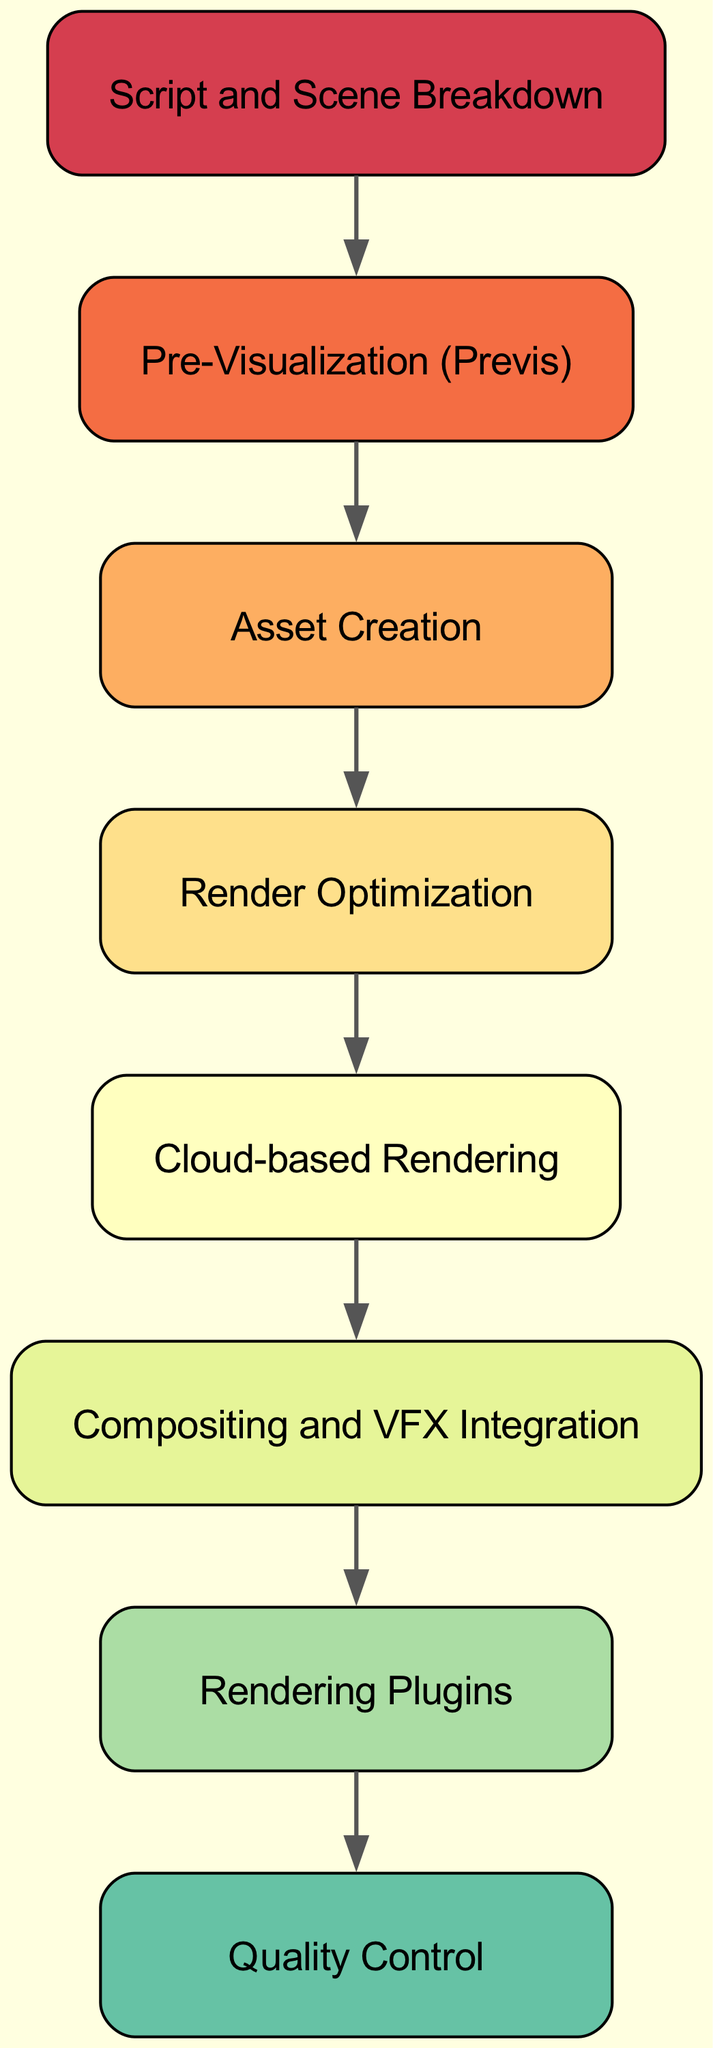What is the first process in the diagram? The first process listed in the diagram is "Script and Scene Breakdown," which is the starting point for analyzing the script and identifying all scenes requiring CGI.
Answer: Script and Scene Breakdown How many processes are involved in the workflow? The diagram contains a total of eight processes listed, each representing a step in the cost-effective CGI workflow.
Answer: Eight What process follows "Asset Creation"? The process that directly follows "Asset Creation" in the workflow is "Render Optimization," which applies techniques to enhance render efficiency.
Answer: Render Optimization Which rendering plugins are mentioned in the diagram? The diagram specifies cost-effective rendering plugins mentioned as "Octane Render, Redshift, or V-Ray" that can improve performance and quality.
Answer: Octane Render, Redshift, V-Ray What is the main purpose of "Cloud-based Rendering"? The main purpose of "Cloud-based Rendering" is to utilize services to minimize hardware costs associated with rendering CGI elements.
Answer: Minimize hardware costs What is the relationship between "Pre-Visualization (Previs)" and "Asset Creation"? "Pre-Visualization (Previs)" leads to "Asset Creation," as the initial mockups help plan and create the required 3D models and assets for the scenes.
Answer: Pre-Visualization leads to Asset Creation What does the "Quality Control" process ensure? The "Quality Control" process ensures that the final output of the CGI elements meets the creative expectations established during production.
Answer: Final output meets expectations Which software is used for "Compositing and VFX Integration"? For "Compositing and VFX Integration," the diagram mentions the use of software like "Adobe After Effects or Nuke."
Answer: Adobe After Effects, Nuke 